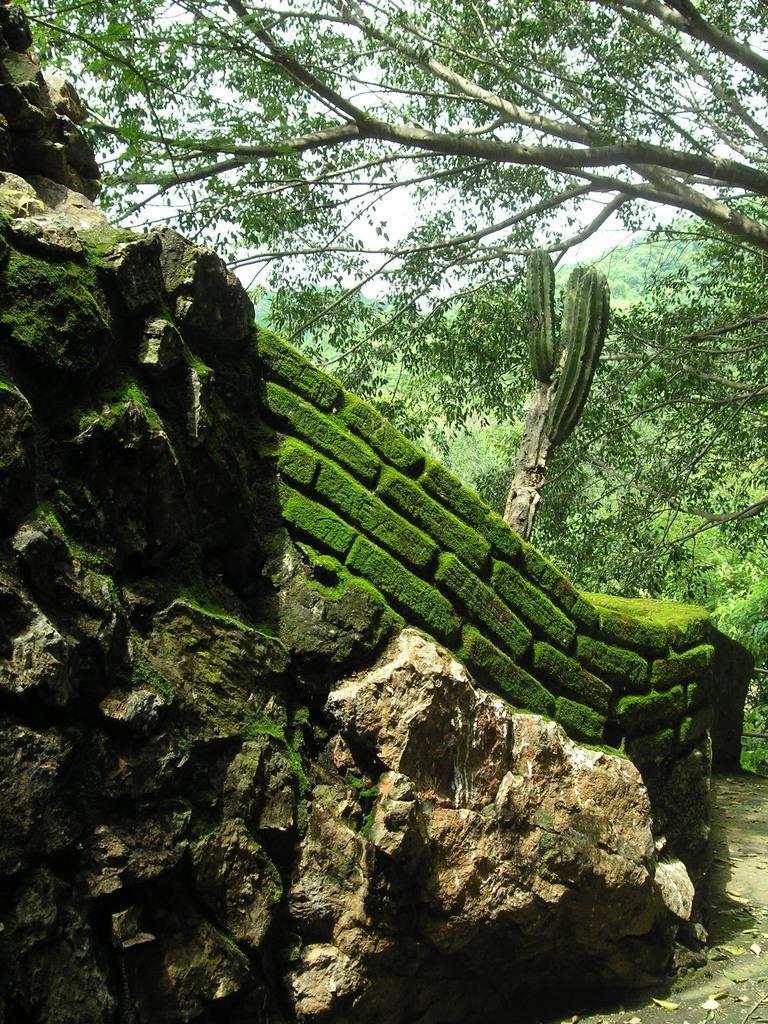How would you summarize this image in a sentence or two? There are rocks. Also there is a brick wall. Near to that there is a cactus plant. In the background there are trees. 